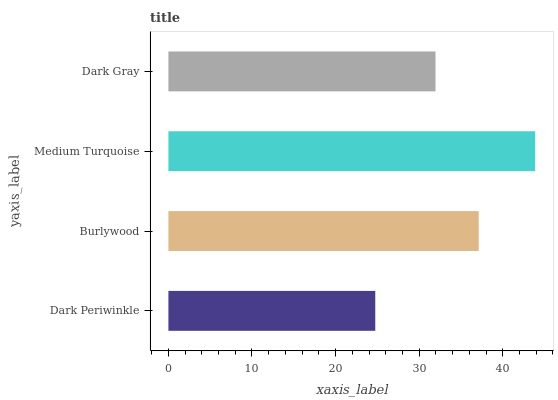Is Dark Periwinkle the minimum?
Answer yes or no. Yes. Is Medium Turquoise the maximum?
Answer yes or no. Yes. Is Burlywood the minimum?
Answer yes or no. No. Is Burlywood the maximum?
Answer yes or no. No. Is Burlywood greater than Dark Periwinkle?
Answer yes or no. Yes. Is Dark Periwinkle less than Burlywood?
Answer yes or no. Yes. Is Dark Periwinkle greater than Burlywood?
Answer yes or no. No. Is Burlywood less than Dark Periwinkle?
Answer yes or no. No. Is Burlywood the high median?
Answer yes or no. Yes. Is Dark Gray the low median?
Answer yes or no. Yes. Is Medium Turquoise the high median?
Answer yes or no. No. Is Medium Turquoise the low median?
Answer yes or no. No. 